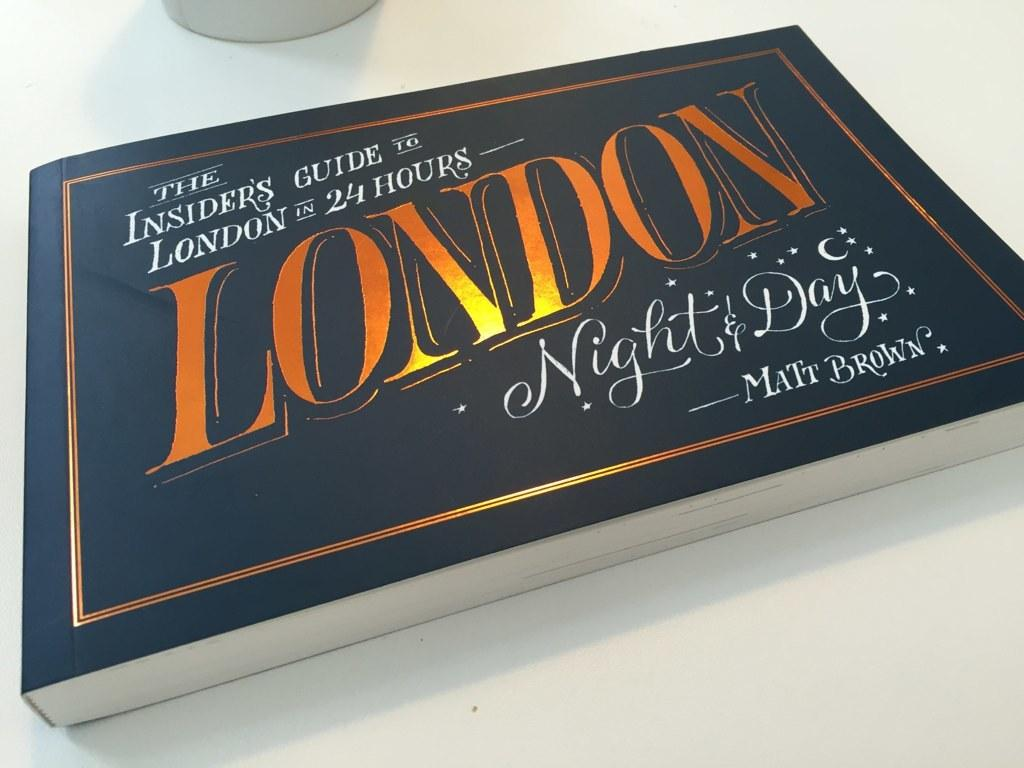<image>
Offer a succinct explanation of the picture presented. Long blue book with London in large and orange letters. 